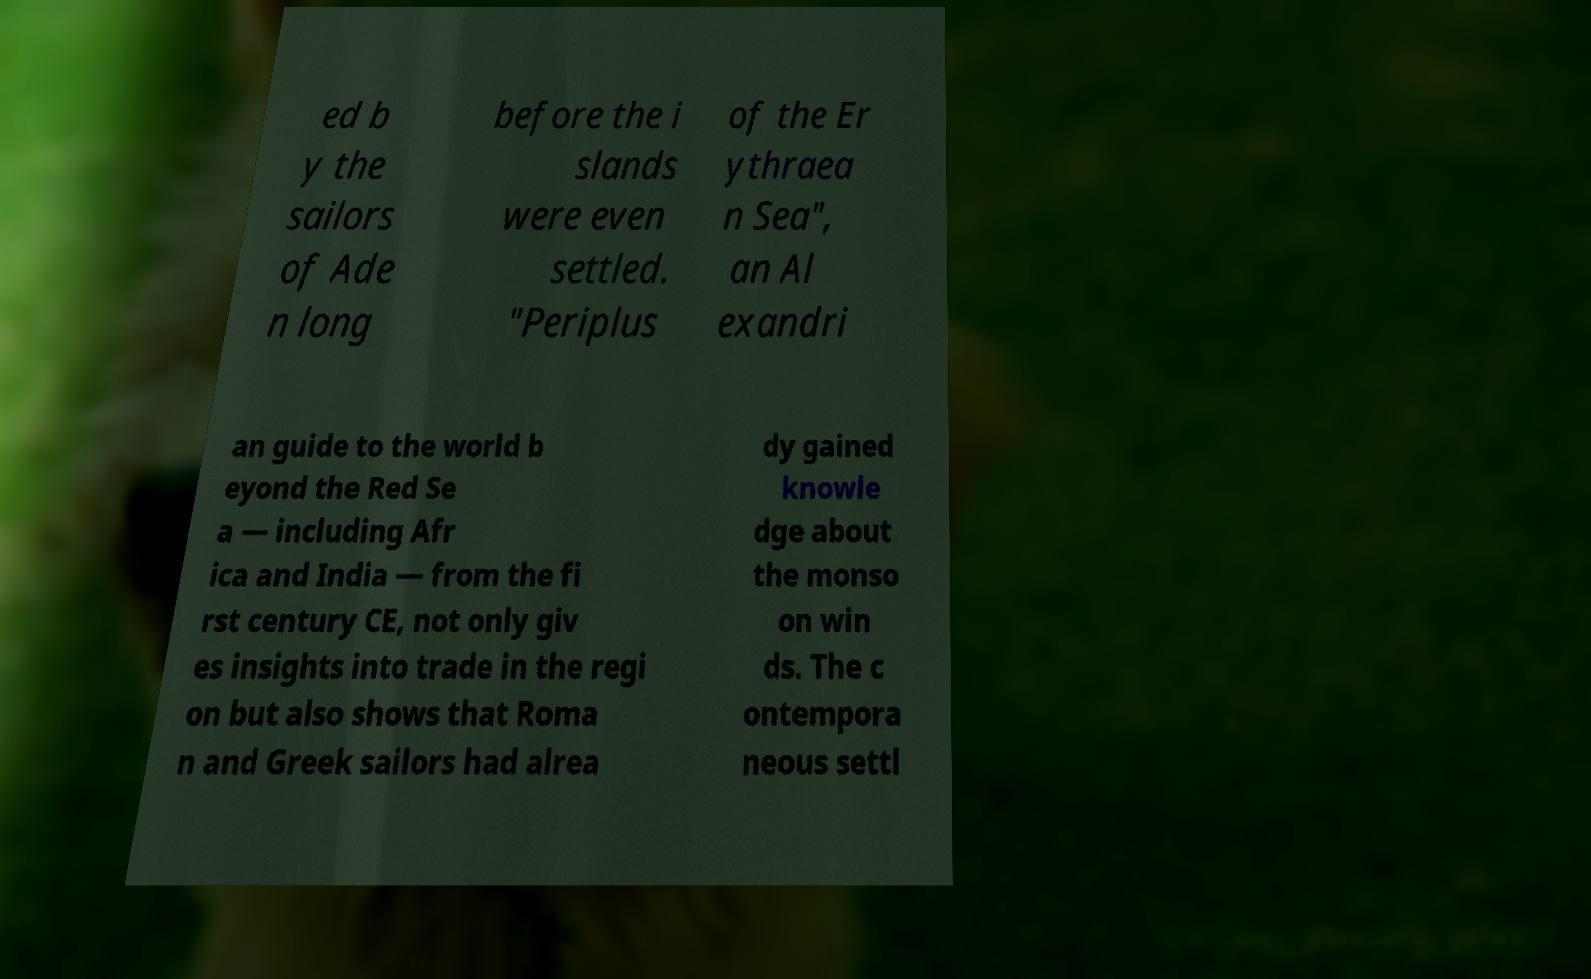Can you accurately transcribe the text from the provided image for me? ed b y the sailors of Ade n long before the i slands were even settled. "Periplus of the Er ythraea n Sea", an Al exandri an guide to the world b eyond the Red Se a — including Afr ica and India — from the fi rst century CE, not only giv es insights into trade in the regi on but also shows that Roma n and Greek sailors had alrea dy gained knowle dge about the monso on win ds. The c ontempora neous settl 